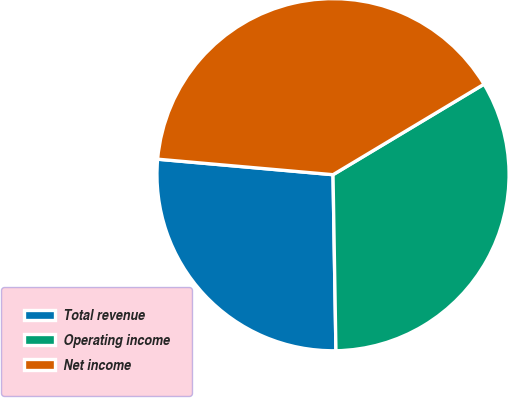Convert chart. <chart><loc_0><loc_0><loc_500><loc_500><pie_chart><fcel>Total revenue<fcel>Operating income<fcel>Net income<nl><fcel>26.67%<fcel>33.33%<fcel>40.0%<nl></chart> 